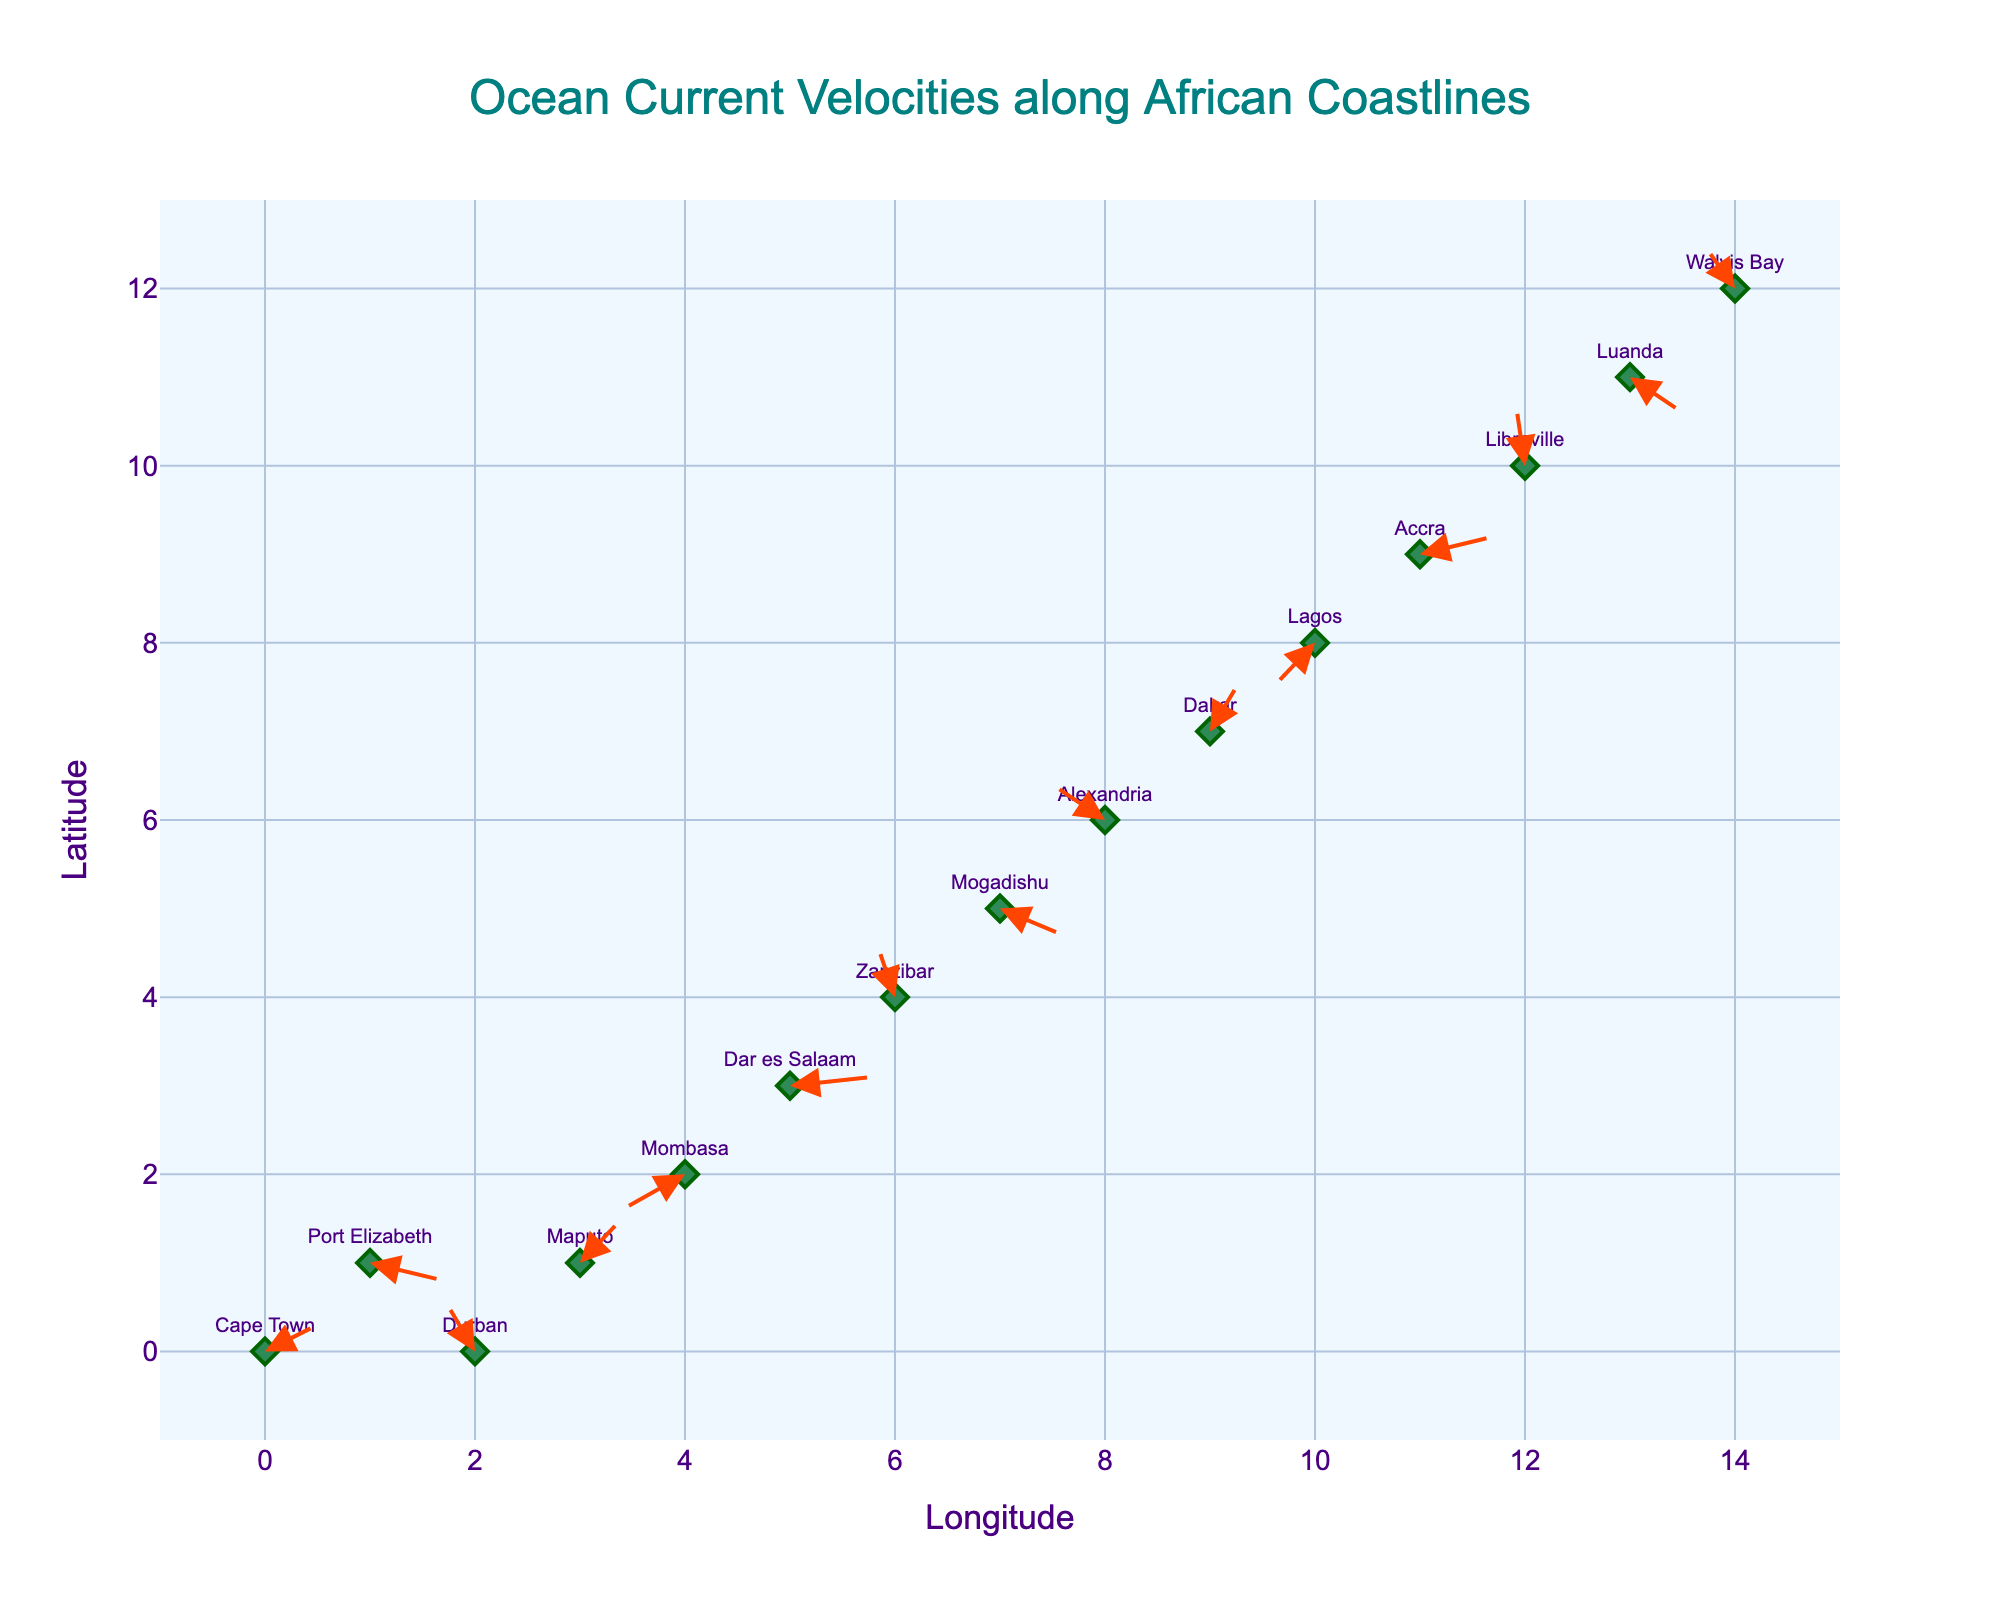What is the title of the quiver plot? The title of the plot is displayed at the top center of the visual. The visual has the title "Ocean Current Velocities along African Coastlines".
Answer: Ocean Current Velocities along African Coastlines How many locations are represented in the quiver plot? To determine the number of locations, count the number of markers or text labels on the plot. The data shows 15 rows, each corresponding to a unique location.
Answer: 15 Which location has the highest velocity in the x-direction? Compare the u components of the arrows. The largest positive value for u is 0.8 at Dar es Salaam.
Answer: Dar es Salaam What is the text color used for the location labels? The color of the text labels can be identified by looking at the appearance of the text labels. They are colored in a shade of purple.
Answer: purple Which locations have arrows pointing southward (negative y-direction)? Review the y components (v) of the arrows. Southward arrows have negative v values. Locations with negative v values are Port Elizabeth, Mombasa, Mogadishu, Lagos, and Luanda.
Answer: Port Elizabeth, Mombasa, Mogadishu, Lagos, Luanda What is the range of the longitude axis? The range of the longitude axis can be inferred from the visual axis limits. The x-axis ranges from -1 to 15.
Answer: -1 to 15 What is the average u value for all locations? Calculate the average of all u values: (0.5 + 0.7 - 0.3 + 0.4 - 0.6 + 0.8 - 0.2 + 0.6 - 0.5 + 0.3 - 0.4 + 0.7 - 0.1 + 0.5 - 0.3) / 15 = 2.9 / 15 = 0.1933
Answer: 0.1933 What are the colors of the arrows showing ocean currents? The arrow colors indicate direction and can be identified by their appearance. The arrows are red in color.
Answer: red Which location has the strongest velocity in the y-direction? Compare the absolute values of the v components. The largest positive value of v is 0.8 at Libreville.
Answer: Libreville Which locations have velocities in the negative x-direction? Identify locations with negative u values. These locations are Durban, Mombasa, Alexandria, Lagos, and Walvis Bay.
Answer: Durban, Mombasa, Alexandria, Lagos, Walvis Bay 